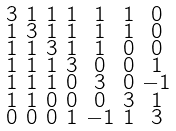Convert formula to latex. <formula><loc_0><loc_0><loc_500><loc_500>\begin{smallmatrix} 3 & 1 & 1 & 1 & 1 & 1 & 0 \\ 1 & 3 & 1 & 1 & 1 & 1 & 0 \\ 1 & 1 & 3 & 1 & 1 & 0 & 0 \\ 1 & 1 & 1 & 3 & 0 & 0 & 1 \\ 1 & 1 & 1 & 0 & 3 & 0 & - 1 \\ 1 & 1 & 0 & 0 & 0 & 3 & 1 \\ 0 & 0 & 0 & 1 & - 1 & 1 & 3 \end{smallmatrix}</formula> 